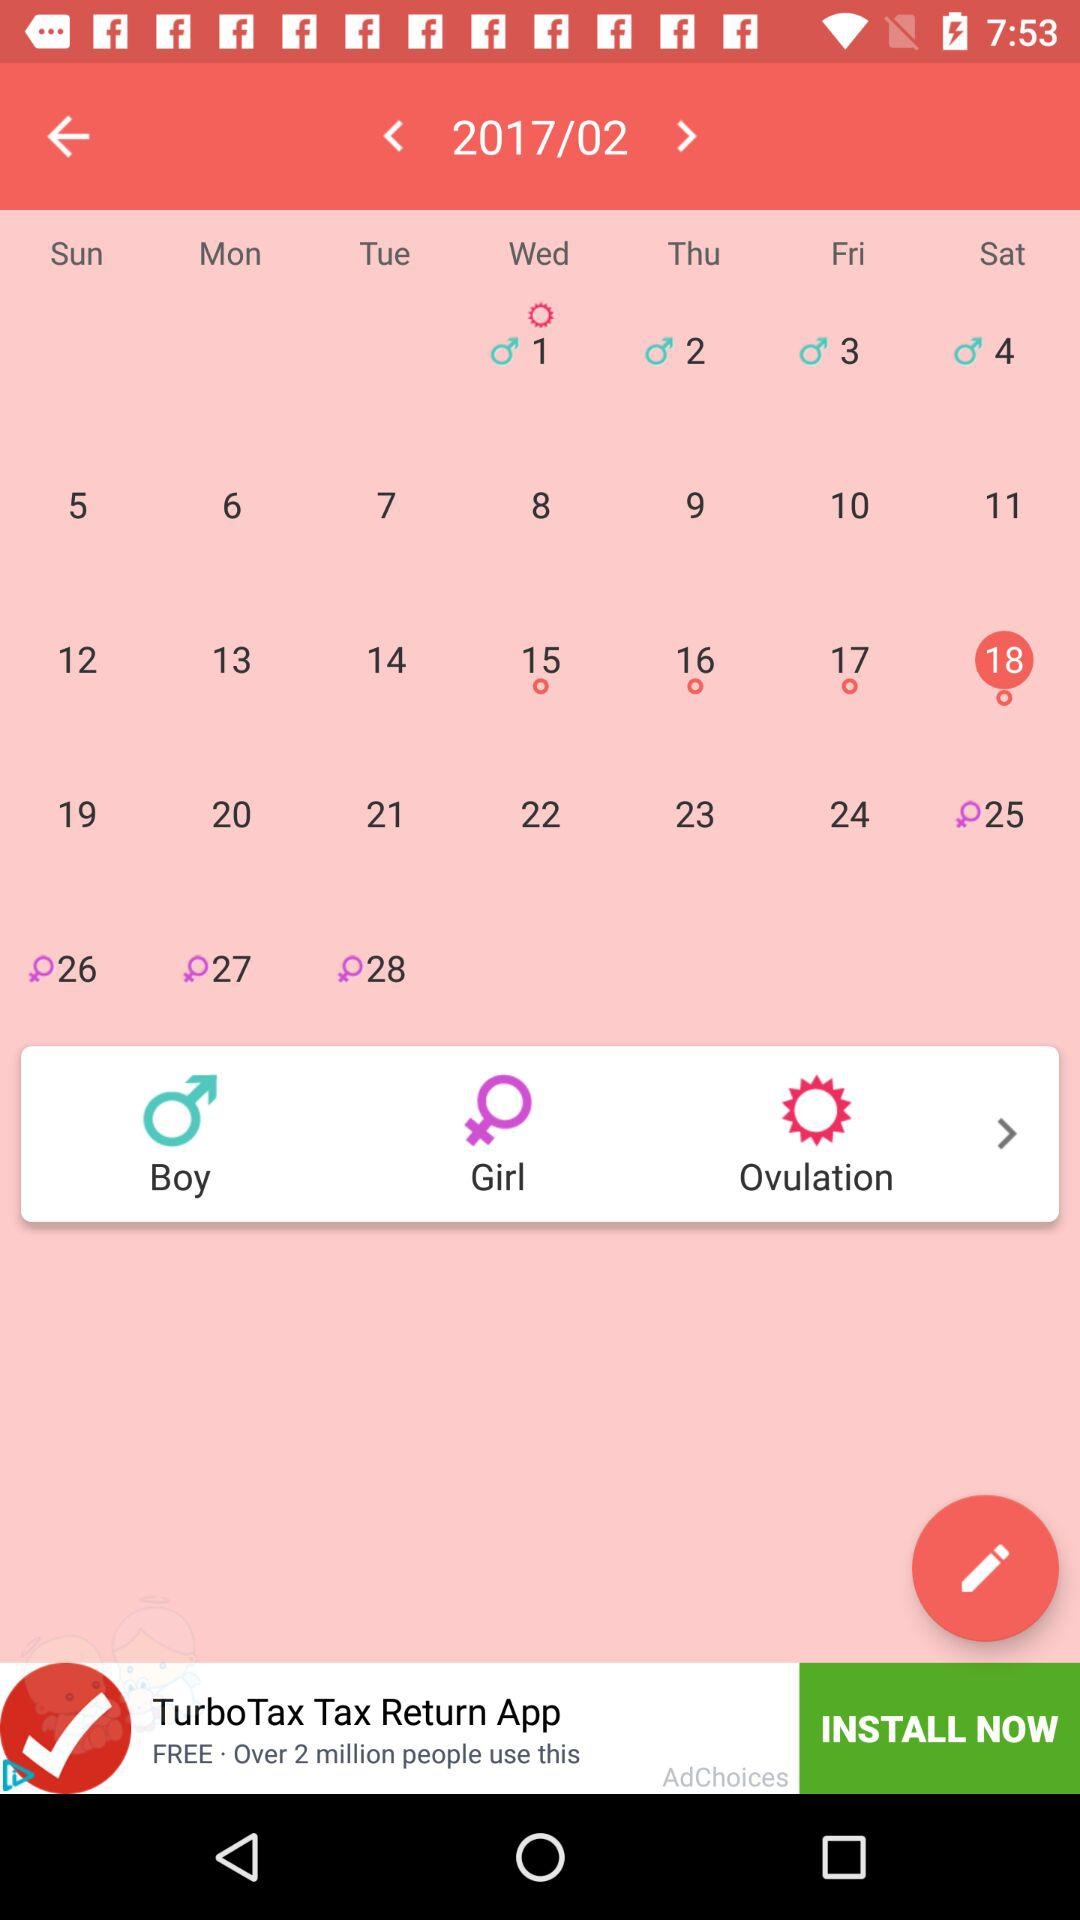What is the selected date in the calendar? The selected date is Saturday, February 18, 2017. 